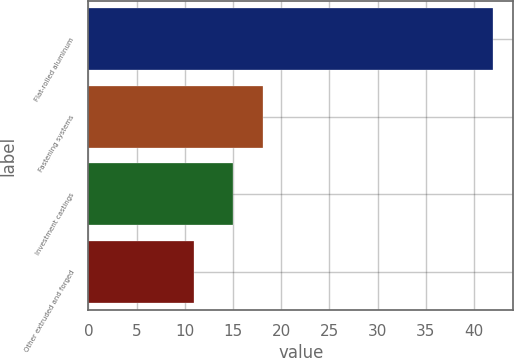<chart> <loc_0><loc_0><loc_500><loc_500><bar_chart><fcel>Flat-rolled aluminum<fcel>Fastening systems<fcel>Investment castings<fcel>Other extruded and forged<nl><fcel>42<fcel>18.1<fcel>15<fcel>11<nl></chart> 